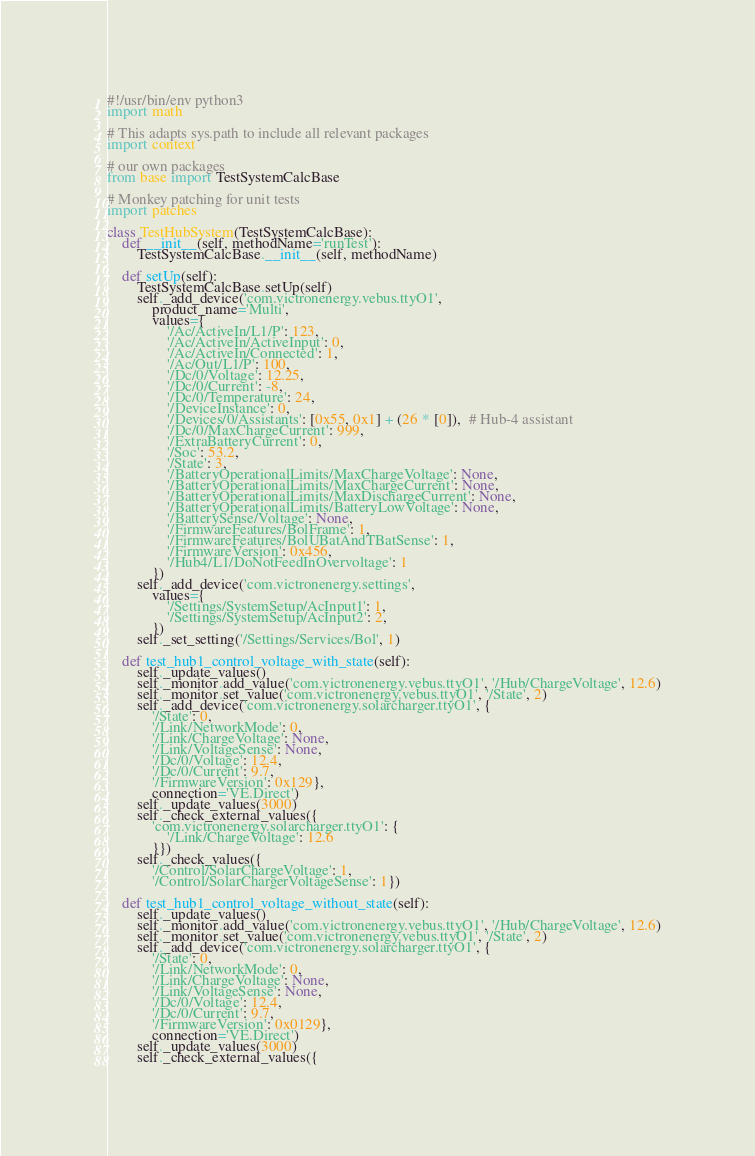<code> <loc_0><loc_0><loc_500><loc_500><_Python_>#!/usr/bin/env python3
import math

# This adapts sys.path to include all relevant packages
import context

# our own packages
from base import TestSystemCalcBase

# Monkey patching for unit tests
import patches

class TestHubSystem(TestSystemCalcBase):
	def __init__(self, methodName='runTest'):
		TestSystemCalcBase.__init__(self, methodName)

	def setUp(self):
		TestSystemCalcBase.setUp(self)
		self._add_device('com.victronenergy.vebus.ttyO1',
			product_name='Multi',
			values={
				'/Ac/ActiveIn/L1/P': 123,
				'/Ac/ActiveIn/ActiveInput': 0,
				'/Ac/ActiveIn/Connected': 1,
				'/Ac/Out/L1/P': 100,
				'/Dc/0/Voltage': 12.25,
				'/Dc/0/Current': -8,
				'/Dc/0/Temperature': 24,
				'/DeviceInstance': 0,
				'/Devices/0/Assistants': [0x55, 0x1] + (26 * [0]),  # Hub-4 assistant
				'/Dc/0/MaxChargeCurrent': 999,
				'/ExtraBatteryCurrent': 0,
				'/Soc': 53.2,
				'/State': 3,
				'/BatteryOperationalLimits/MaxChargeVoltage': None,
				'/BatteryOperationalLimits/MaxChargeCurrent': None,
				'/BatteryOperationalLimits/MaxDischargeCurrent': None,
				'/BatteryOperationalLimits/BatteryLowVoltage': None,
				'/BatterySense/Voltage': None,
				'/FirmwareFeatures/BolFrame': 1,
				'/FirmwareFeatures/BolUBatAndTBatSense': 1,
				'/FirmwareVersion': 0x456,
				'/Hub4/L1/DoNotFeedInOvervoltage': 1
			})
		self._add_device('com.victronenergy.settings',
			values={
				'/Settings/SystemSetup/AcInput1': 1,
				'/Settings/SystemSetup/AcInput2': 2,
			})
		self._set_setting('/Settings/Services/Bol', 1)

	def test_hub1_control_voltage_with_state(self):
		self._update_values()
		self._monitor.add_value('com.victronenergy.vebus.ttyO1', '/Hub/ChargeVoltage', 12.6)
		self._monitor.set_value('com.victronenergy.vebus.ttyO1', '/State', 2)
		self._add_device('com.victronenergy.solarcharger.ttyO1', {
			'/State': 0,
			'/Link/NetworkMode': 0,
			'/Link/ChargeVoltage': None,
			'/Link/VoltageSense': None,
			'/Dc/0/Voltage': 12.4,
			'/Dc/0/Current': 9.7,
			'/FirmwareVersion': 0x129},
			connection='VE.Direct')
		self._update_values(3000)
		self._check_external_values({
			'com.victronenergy.solarcharger.ttyO1': {
				'/Link/ChargeVoltage': 12.6
			}})
		self._check_values({
			'/Control/SolarChargeVoltage': 1,
			'/Control/SolarChargerVoltageSense': 1})

	def test_hub1_control_voltage_without_state(self):
		self._update_values()
		self._monitor.add_value('com.victronenergy.vebus.ttyO1', '/Hub/ChargeVoltage', 12.6)
		self._monitor.set_value('com.victronenergy.vebus.ttyO1', '/State', 2)
		self._add_device('com.victronenergy.solarcharger.ttyO1', {
			'/State': 0,
			'/Link/NetworkMode': 0,
			'/Link/ChargeVoltage': None,
			'/Link/VoltageSense': None,
			'/Dc/0/Voltage': 12.4,
			'/Dc/0/Current': 9.7,
			'/FirmwareVersion': 0x0129},
			connection='VE.Direct')
		self._update_values(3000)
		self._check_external_values({</code> 